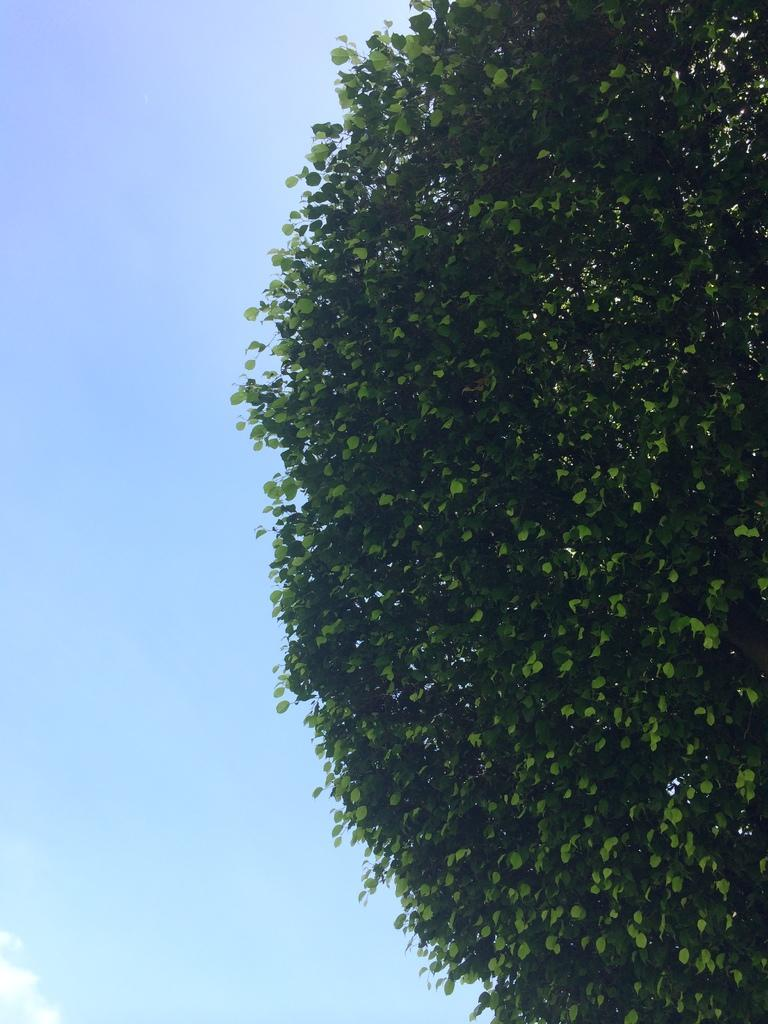What type of vegetation can be seen in the image? There are leaves of a tree in the image. What can be seen in the sky in the image? There are clouds visible in the sky at the bottom of the image. Can you describe the monkey's sense of humor in the image? There is no monkey present in the image, so it is not possible to describe its sense of humor. 